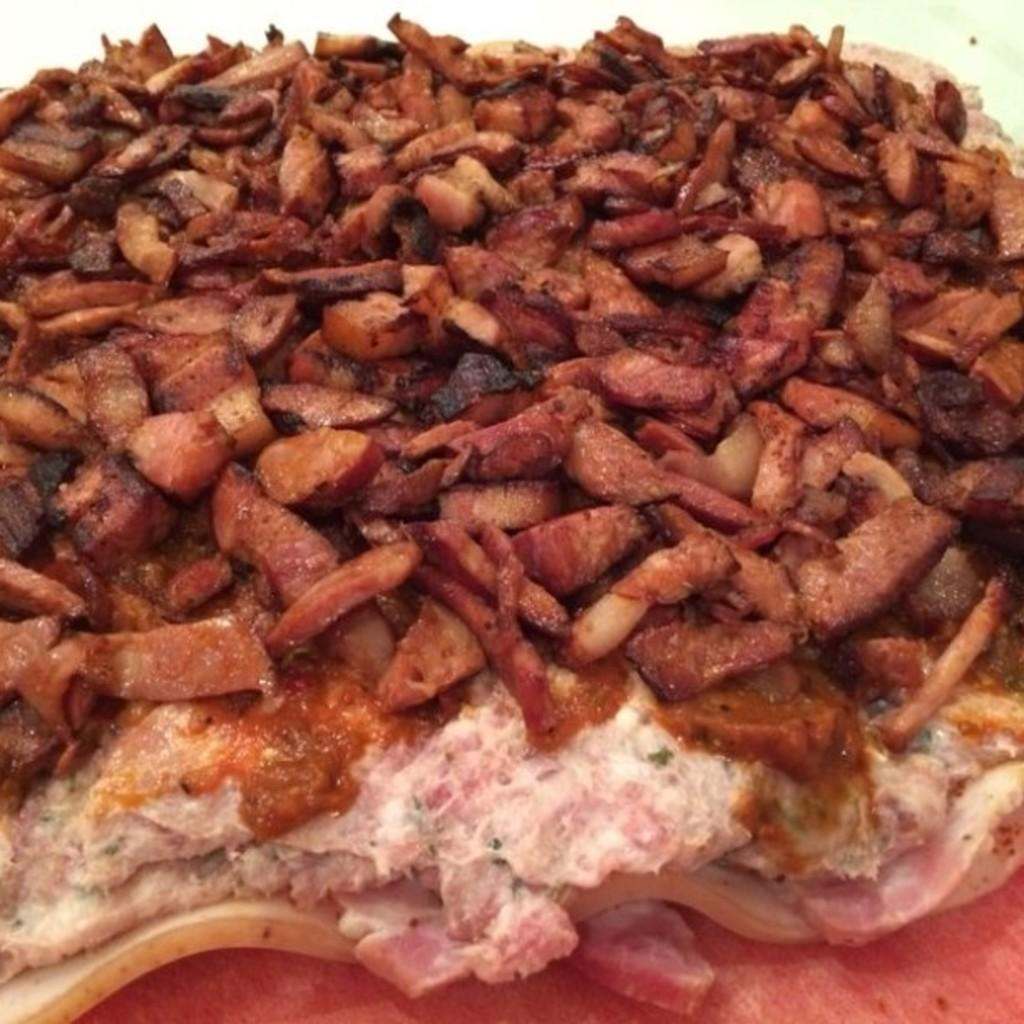What type of food is visible in the image? There are meat pieces and fried pieces in the image. Where are the meat pieces and fried pieces located? Both the meat pieces and fried pieces are on a table. What can be seen in the top right corner of the image? There is a wall in the top right corner of the image. What type of knowledge does the grandmother have about the butter in the image? There is no grandmother or butter present in the image. 